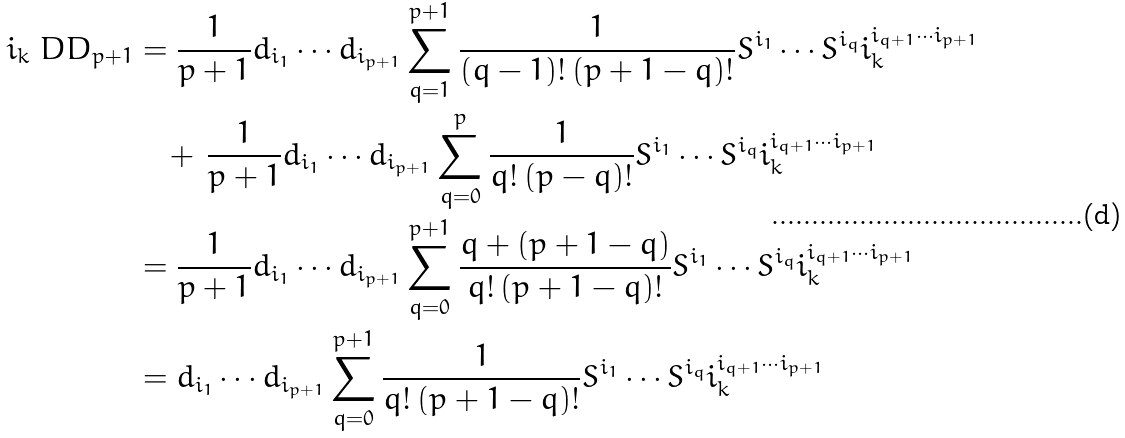<formula> <loc_0><loc_0><loc_500><loc_500>i _ { k } \ D D _ { p + 1 } & = \frac { 1 } { p + 1 } d _ { i _ { 1 } } \cdots d _ { i _ { p + 1 } } \sum _ { q = 1 } ^ { p + 1 } \frac { 1 } { ( q - 1 ) ! \, ( p + 1 - q ) ! } S ^ { i _ { 1 } } \cdots S ^ { i _ { q } } i ^ { i _ { q + 1 } \cdots i _ { p + 1 } } _ { k } \\ & \quad + \, \frac { 1 } { p + 1 } d _ { i _ { 1 } } \cdots d _ { i _ { p + 1 } } \sum _ { q = 0 } ^ { p } \frac { 1 } { q ! \, ( p - q ) ! } S ^ { i _ { 1 } } \cdots S ^ { i _ { q } } i ^ { i _ { q + 1 } \cdots i _ { p + 1 } } _ { k } \\ & = \frac { 1 } { p + 1 } d _ { i _ { 1 } } \cdots d _ { i _ { p + 1 } } \sum _ { q = 0 } ^ { p + 1 } \frac { q + ( p + 1 - q ) } { q ! \, ( p + 1 - q ) ! } S ^ { i _ { 1 } } \cdots S ^ { i _ { q } } i ^ { i _ { q + 1 } \cdots i _ { p + 1 } } _ { k } \\ & = d _ { i _ { 1 } } \cdots d _ { i _ { p + 1 } } \sum _ { q = 0 } ^ { p + 1 } \frac { 1 } { q ! \, ( p + 1 - q ) ! } S ^ { i _ { 1 } } \cdots S ^ { i _ { q } } i ^ { i _ { q + 1 } \cdots i _ { p + 1 } } _ { k }</formula> 